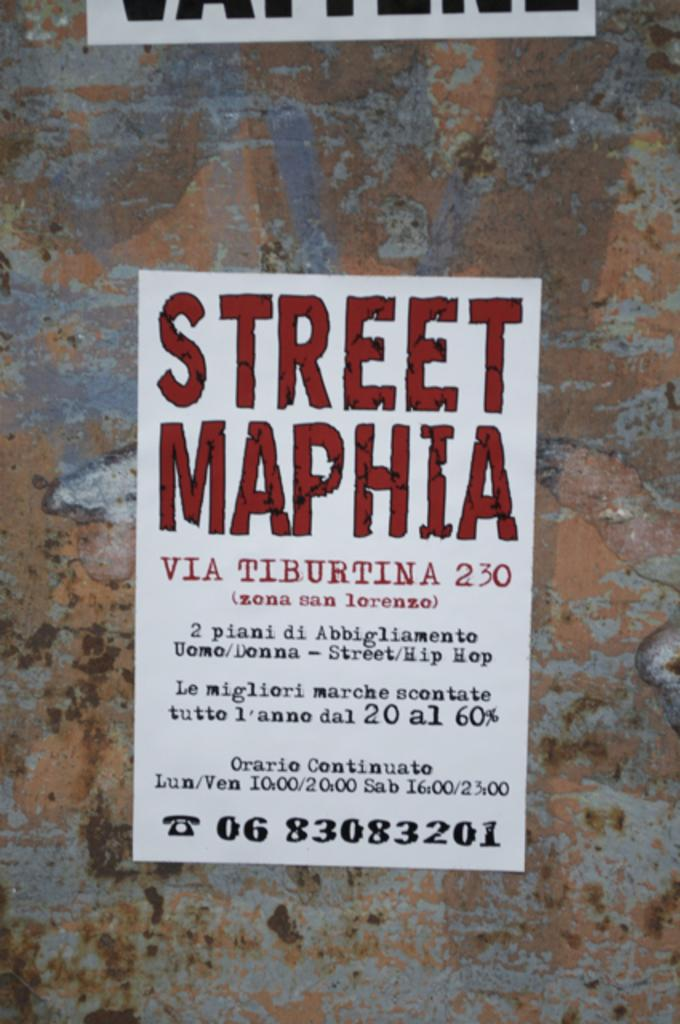<image>
Describe the image concisely. a street maphia sign on a colored surface 